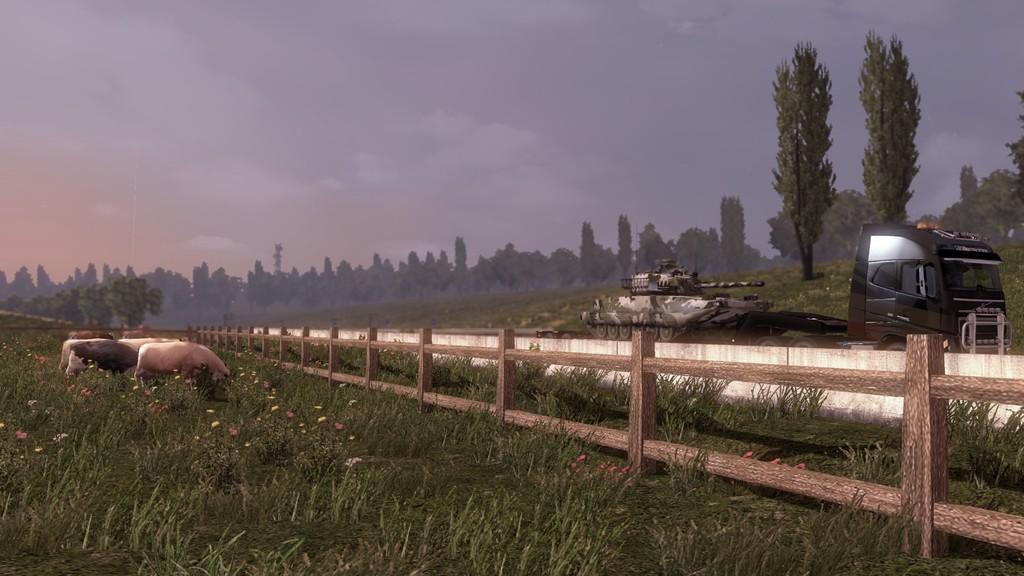Could you give a brief overview of what you see in this image? Animated picture. Here we can see fence, vehicles, animals, flowers and grass. Background there are trees and sky. Sky is cloudy. 